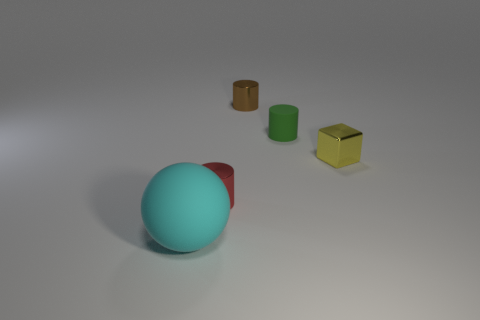Is there anything else that is the same size as the cyan rubber sphere?
Ensure brevity in your answer.  No. There is a green thing that is the same shape as the red thing; what is its material?
Keep it short and to the point. Rubber. What color is the object that is in front of the yellow metallic object and behind the cyan ball?
Provide a succinct answer. Red. The block is what color?
Your answer should be compact. Yellow. Is there another matte thing of the same shape as the yellow object?
Ensure brevity in your answer.  No. How big is the shiny object that is in front of the tiny yellow thing?
Ensure brevity in your answer.  Small. What is the material of the brown cylinder that is the same size as the red cylinder?
Your answer should be compact. Metal. Are there more tiny yellow blocks than small rubber spheres?
Offer a very short reply. Yes. There is a rubber object on the right side of the tiny shiny object that is behind the cube; what size is it?
Your response must be concise. Small. There is a green object that is the same size as the brown cylinder; what shape is it?
Offer a terse response. Cylinder. 